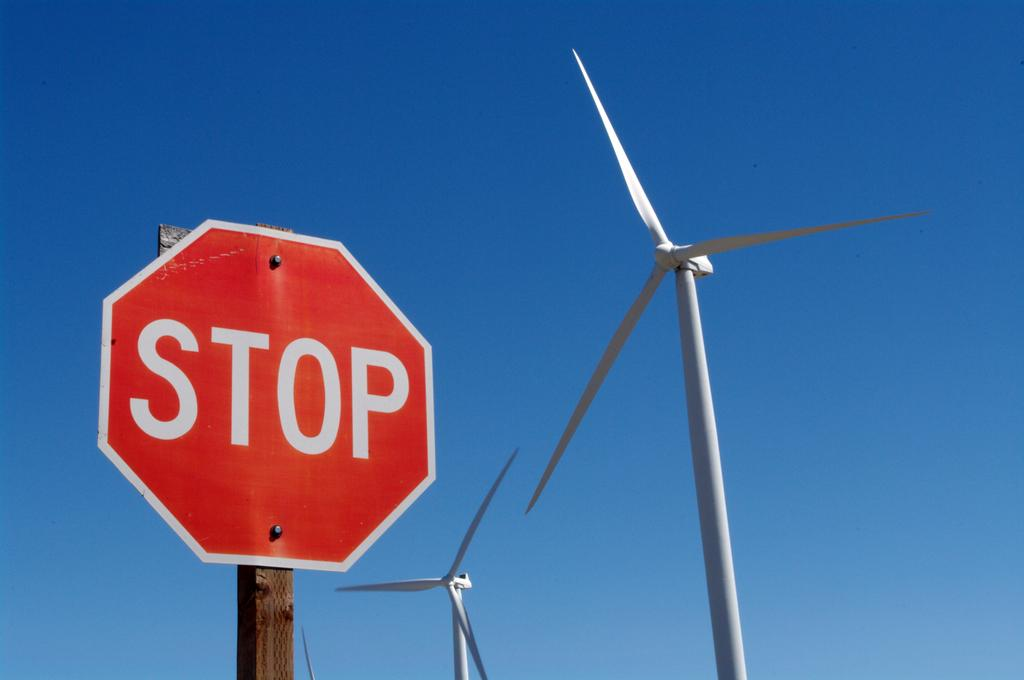What is on the signboard that is visible in the image? There is text on the signboard in the image. How is the signboard positioned in the image? The signboard is placed on a pole. What can be seen in the background of the image? Turbines and the sky are visible in the background of the image. What type of flag is waving in the image? There is no flag present in the image; it features a signboard with text, a pole, turbines, and the sky. 